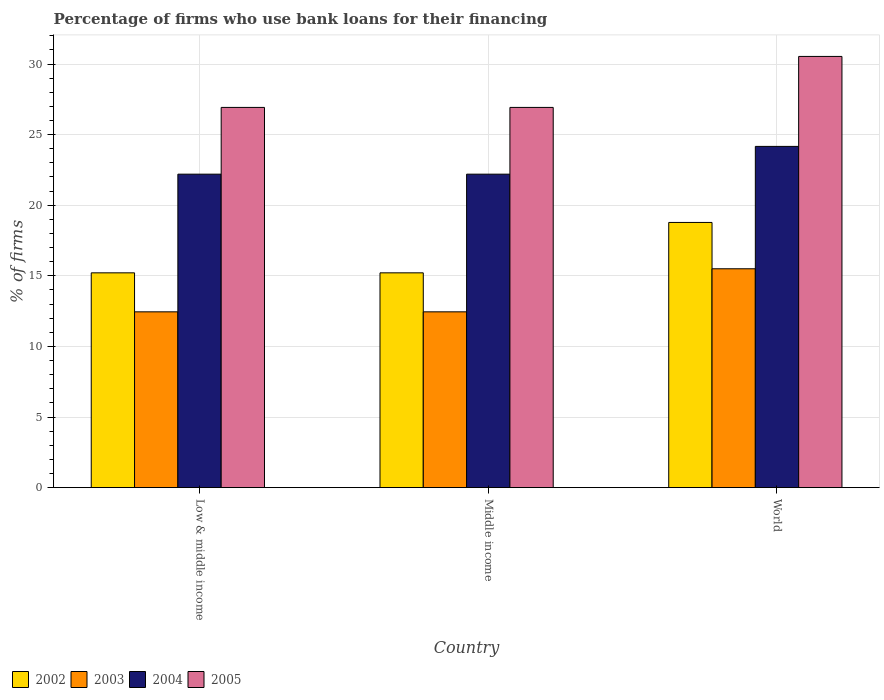How many groups of bars are there?
Offer a very short reply. 3. Are the number of bars on each tick of the X-axis equal?
Provide a short and direct response. Yes. What is the label of the 2nd group of bars from the left?
Your response must be concise. Middle income. What is the percentage of firms who use bank loans for their financing in 2003 in Middle income?
Provide a short and direct response. 12.45. Across all countries, what is the maximum percentage of firms who use bank loans for their financing in 2005?
Your answer should be compact. 30.54. Across all countries, what is the minimum percentage of firms who use bank loans for their financing in 2005?
Offer a terse response. 26.93. In which country was the percentage of firms who use bank loans for their financing in 2004 maximum?
Offer a terse response. World. In which country was the percentage of firms who use bank loans for their financing in 2003 minimum?
Your answer should be very brief. Low & middle income. What is the total percentage of firms who use bank loans for their financing in 2003 in the graph?
Your answer should be very brief. 40.4. What is the difference between the percentage of firms who use bank loans for their financing in 2005 in Low & middle income and that in Middle income?
Offer a terse response. 0. What is the difference between the percentage of firms who use bank loans for their financing in 2005 in Low & middle income and the percentage of firms who use bank loans for their financing in 2002 in Middle income?
Ensure brevity in your answer.  11.72. What is the average percentage of firms who use bank loans for their financing in 2005 per country?
Offer a terse response. 28.13. What is the difference between the percentage of firms who use bank loans for their financing of/in 2004 and percentage of firms who use bank loans for their financing of/in 2002 in Low & middle income?
Keep it short and to the point. 6.99. What is the difference between the highest and the second highest percentage of firms who use bank loans for their financing in 2002?
Offer a very short reply. 3.57. What is the difference between the highest and the lowest percentage of firms who use bank loans for their financing in 2002?
Your answer should be very brief. 3.57. Is it the case that in every country, the sum of the percentage of firms who use bank loans for their financing in 2005 and percentage of firms who use bank loans for their financing in 2003 is greater than the sum of percentage of firms who use bank loans for their financing in 2002 and percentage of firms who use bank loans for their financing in 2004?
Your answer should be compact. Yes. What does the 3rd bar from the left in Middle income represents?
Offer a terse response. 2004. What does the 1st bar from the right in Low & middle income represents?
Keep it short and to the point. 2005. How many bars are there?
Provide a short and direct response. 12. Are the values on the major ticks of Y-axis written in scientific E-notation?
Give a very brief answer. No. Does the graph contain grids?
Keep it short and to the point. Yes. How many legend labels are there?
Keep it short and to the point. 4. How are the legend labels stacked?
Your answer should be very brief. Horizontal. What is the title of the graph?
Provide a succinct answer. Percentage of firms who use bank loans for their financing. Does "2001" appear as one of the legend labels in the graph?
Ensure brevity in your answer.  No. What is the label or title of the X-axis?
Provide a short and direct response. Country. What is the label or title of the Y-axis?
Your answer should be very brief. % of firms. What is the % of firms of 2002 in Low & middle income?
Ensure brevity in your answer.  15.21. What is the % of firms of 2003 in Low & middle income?
Make the answer very short. 12.45. What is the % of firms of 2005 in Low & middle income?
Give a very brief answer. 26.93. What is the % of firms of 2002 in Middle income?
Ensure brevity in your answer.  15.21. What is the % of firms of 2003 in Middle income?
Make the answer very short. 12.45. What is the % of firms of 2005 in Middle income?
Your answer should be compact. 26.93. What is the % of firms of 2002 in World?
Provide a short and direct response. 18.78. What is the % of firms of 2003 in World?
Offer a terse response. 15.5. What is the % of firms in 2004 in World?
Your answer should be very brief. 24.17. What is the % of firms in 2005 in World?
Provide a short and direct response. 30.54. Across all countries, what is the maximum % of firms of 2002?
Offer a terse response. 18.78. Across all countries, what is the maximum % of firms in 2004?
Ensure brevity in your answer.  24.17. Across all countries, what is the maximum % of firms in 2005?
Keep it short and to the point. 30.54. Across all countries, what is the minimum % of firms in 2002?
Provide a short and direct response. 15.21. Across all countries, what is the minimum % of firms of 2003?
Provide a succinct answer. 12.45. Across all countries, what is the minimum % of firms in 2004?
Your answer should be very brief. 22.2. Across all countries, what is the minimum % of firms of 2005?
Keep it short and to the point. 26.93. What is the total % of firms in 2002 in the graph?
Provide a succinct answer. 49.21. What is the total % of firms in 2003 in the graph?
Keep it short and to the point. 40.4. What is the total % of firms in 2004 in the graph?
Offer a terse response. 68.57. What is the total % of firms in 2005 in the graph?
Offer a very short reply. 84.39. What is the difference between the % of firms in 2005 in Low & middle income and that in Middle income?
Give a very brief answer. 0. What is the difference between the % of firms in 2002 in Low & middle income and that in World?
Your answer should be compact. -3.57. What is the difference between the % of firms in 2003 in Low & middle income and that in World?
Offer a very short reply. -3.05. What is the difference between the % of firms of 2004 in Low & middle income and that in World?
Your answer should be very brief. -1.97. What is the difference between the % of firms in 2005 in Low & middle income and that in World?
Give a very brief answer. -3.61. What is the difference between the % of firms of 2002 in Middle income and that in World?
Keep it short and to the point. -3.57. What is the difference between the % of firms in 2003 in Middle income and that in World?
Ensure brevity in your answer.  -3.05. What is the difference between the % of firms of 2004 in Middle income and that in World?
Your answer should be compact. -1.97. What is the difference between the % of firms in 2005 in Middle income and that in World?
Offer a very short reply. -3.61. What is the difference between the % of firms in 2002 in Low & middle income and the % of firms in 2003 in Middle income?
Keep it short and to the point. 2.76. What is the difference between the % of firms of 2002 in Low & middle income and the % of firms of 2004 in Middle income?
Your answer should be very brief. -6.99. What is the difference between the % of firms in 2002 in Low & middle income and the % of firms in 2005 in Middle income?
Offer a terse response. -11.72. What is the difference between the % of firms in 2003 in Low & middle income and the % of firms in 2004 in Middle income?
Make the answer very short. -9.75. What is the difference between the % of firms in 2003 in Low & middle income and the % of firms in 2005 in Middle income?
Offer a terse response. -14.48. What is the difference between the % of firms of 2004 in Low & middle income and the % of firms of 2005 in Middle income?
Your response must be concise. -4.73. What is the difference between the % of firms in 2002 in Low & middle income and the % of firms in 2003 in World?
Offer a very short reply. -0.29. What is the difference between the % of firms in 2002 in Low & middle income and the % of firms in 2004 in World?
Your answer should be compact. -8.95. What is the difference between the % of firms in 2002 in Low & middle income and the % of firms in 2005 in World?
Offer a very short reply. -15.33. What is the difference between the % of firms in 2003 in Low & middle income and the % of firms in 2004 in World?
Provide a short and direct response. -11.72. What is the difference between the % of firms of 2003 in Low & middle income and the % of firms of 2005 in World?
Ensure brevity in your answer.  -18.09. What is the difference between the % of firms of 2004 in Low & middle income and the % of firms of 2005 in World?
Offer a very short reply. -8.34. What is the difference between the % of firms in 2002 in Middle income and the % of firms in 2003 in World?
Make the answer very short. -0.29. What is the difference between the % of firms of 2002 in Middle income and the % of firms of 2004 in World?
Provide a short and direct response. -8.95. What is the difference between the % of firms of 2002 in Middle income and the % of firms of 2005 in World?
Your response must be concise. -15.33. What is the difference between the % of firms in 2003 in Middle income and the % of firms in 2004 in World?
Offer a very short reply. -11.72. What is the difference between the % of firms of 2003 in Middle income and the % of firms of 2005 in World?
Offer a terse response. -18.09. What is the difference between the % of firms of 2004 in Middle income and the % of firms of 2005 in World?
Offer a terse response. -8.34. What is the average % of firms in 2002 per country?
Ensure brevity in your answer.  16.4. What is the average % of firms of 2003 per country?
Your response must be concise. 13.47. What is the average % of firms of 2004 per country?
Your answer should be compact. 22.86. What is the average % of firms of 2005 per country?
Give a very brief answer. 28.13. What is the difference between the % of firms of 2002 and % of firms of 2003 in Low & middle income?
Make the answer very short. 2.76. What is the difference between the % of firms of 2002 and % of firms of 2004 in Low & middle income?
Ensure brevity in your answer.  -6.99. What is the difference between the % of firms in 2002 and % of firms in 2005 in Low & middle income?
Keep it short and to the point. -11.72. What is the difference between the % of firms in 2003 and % of firms in 2004 in Low & middle income?
Your answer should be very brief. -9.75. What is the difference between the % of firms of 2003 and % of firms of 2005 in Low & middle income?
Offer a very short reply. -14.48. What is the difference between the % of firms of 2004 and % of firms of 2005 in Low & middle income?
Your response must be concise. -4.73. What is the difference between the % of firms in 2002 and % of firms in 2003 in Middle income?
Offer a terse response. 2.76. What is the difference between the % of firms of 2002 and % of firms of 2004 in Middle income?
Your answer should be very brief. -6.99. What is the difference between the % of firms in 2002 and % of firms in 2005 in Middle income?
Make the answer very short. -11.72. What is the difference between the % of firms of 2003 and % of firms of 2004 in Middle income?
Make the answer very short. -9.75. What is the difference between the % of firms in 2003 and % of firms in 2005 in Middle income?
Ensure brevity in your answer.  -14.48. What is the difference between the % of firms in 2004 and % of firms in 2005 in Middle income?
Keep it short and to the point. -4.73. What is the difference between the % of firms in 2002 and % of firms in 2003 in World?
Ensure brevity in your answer.  3.28. What is the difference between the % of firms in 2002 and % of firms in 2004 in World?
Offer a terse response. -5.39. What is the difference between the % of firms in 2002 and % of firms in 2005 in World?
Offer a terse response. -11.76. What is the difference between the % of firms of 2003 and % of firms of 2004 in World?
Offer a very short reply. -8.67. What is the difference between the % of firms of 2003 and % of firms of 2005 in World?
Keep it short and to the point. -15.04. What is the difference between the % of firms in 2004 and % of firms in 2005 in World?
Offer a very short reply. -6.37. What is the ratio of the % of firms in 2002 in Low & middle income to that in Middle income?
Give a very brief answer. 1. What is the ratio of the % of firms of 2005 in Low & middle income to that in Middle income?
Give a very brief answer. 1. What is the ratio of the % of firms in 2002 in Low & middle income to that in World?
Ensure brevity in your answer.  0.81. What is the ratio of the % of firms in 2003 in Low & middle income to that in World?
Provide a short and direct response. 0.8. What is the ratio of the % of firms of 2004 in Low & middle income to that in World?
Offer a very short reply. 0.92. What is the ratio of the % of firms in 2005 in Low & middle income to that in World?
Provide a short and direct response. 0.88. What is the ratio of the % of firms of 2002 in Middle income to that in World?
Ensure brevity in your answer.  0.81. What is the ratio of the % of firms in 2003 in Middle income to that in World?
Give a very brief answer. 0.8. What is the ratio of the % of firms in 2004 in Middle income to that in World?
Your response must be concise. 0.92. What is the ratio of the % of firms in 2005 in Middle income to that in World?
Your response must be concise. 0.88. What is the difference between the highest and the second highest % of firms in 2002?
Ensure brevity in your answer.  3.57. What is the difference between the highest and the second highest % of firms in 2003?
Offer a terse response. 3.05. What is the difference between the highest and the second highest % of firms in 2004?
Provide a short and direct response. 1.97. What is the difference between the highest and the second highest % of firms of 2005?
Give a very brief answer. 3.61. What is the difference between the highest and the lowest % of firms of 2002?
Provide a short and direct response. 3.57. What is the difference between the highest and the lowest % of firms of 2003?
Give a very brief answer. 3.05. What is the difference between the highest and the lowest % of firms of 2004?
Your answer should be compact. 1.97. What is the difference between the highest and the lowest % of firms in 2005?
Provide a succinct answer. 3.61. 